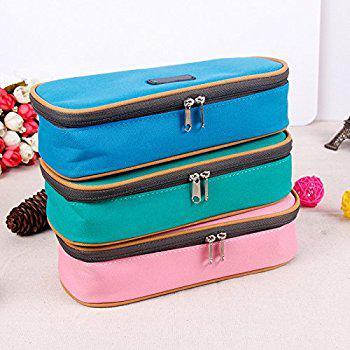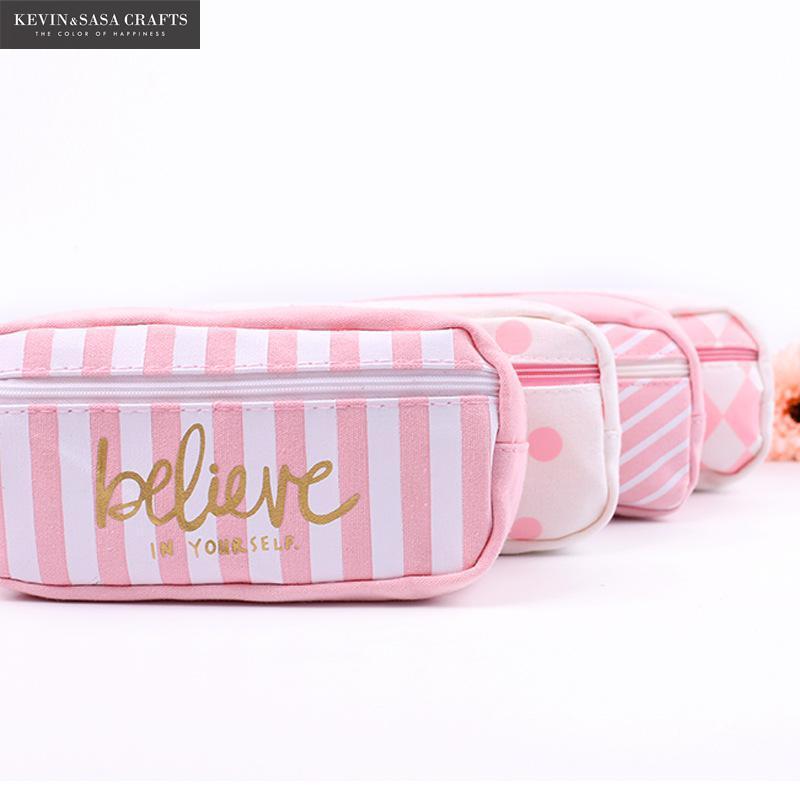The first image is the image on the left, the second image is the image on the right. For the images shown, is this caption "the right image has a pencil pouch with 2 front pockets and two zippers on top" true? Answer yes or no. No. The first image is the image on the left, the second image is the image on the right. Analyze the images presented: Is the assertion "The image on the right has a double zipper." valid? Answer yes or no. No. 